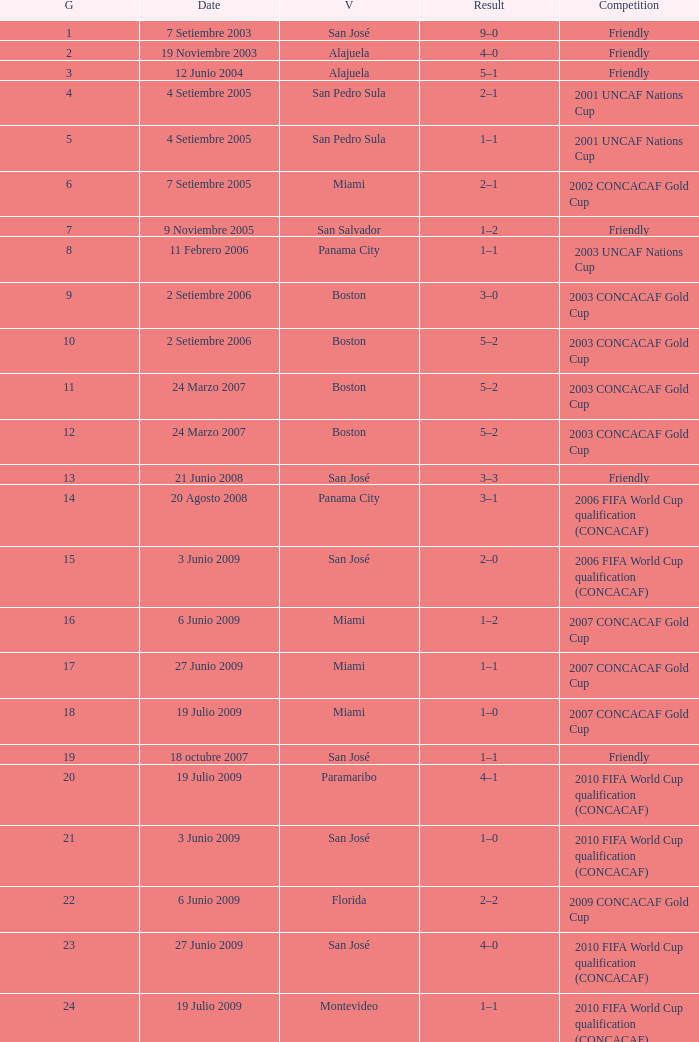Could you parse the entire table as a dict? {'header': ['G', 'Date', 'V', 'Result', 'Competition'], 'rows': [['1', '7 Setiembre 2003', 'San José', '9–0', 'Friendly'], ['2', '19 Noviembre 2003', 'Alajuela', '4–0', 'Friendly'], ['3', '12 Junio 2004', 'Alajuela', '5–1', 'Friendly'], ['4', '4 Setiembre 2005', 'San Pedro Sula', '2–1', '2001 UNCAF Nations Cup'], ['5', '4 Setiembre 2005', 'San Pedro Sula', '1–1', '2001 UNCAF Nations Cup'], ['6', '7 Setiembre 2005', 'Miami', '2–1', '2002 CONCACAF Gold Cup'], ['7', '9 Noviembre 2005', 'San Salvador', '1–2', 'Friendly'], ['8', '11 Febrero 2006', 'Panama City', '1–1', '2003 UNCAF Nations Cup'], ['9', '2 Setiembre 2006', 'Boston', '3–0', '2003 CONCACAF Gold Cup'], ['10', '2 Setiembre 2006', 'Boston', '5–2', '2003 CONCACAF Gold Cup'], ['11', '24 Marzo 2007', 'Boston', '5–2', '2003 CONCACAF Gold Cup'], ['12', '24 Marzo 2007', 'Boston', '5–2', '2003 CONCACAF Gold Cup'], ['13', '21 Junio 2008', 'San José', '3–3', 'Friendly'], ['14', '20 Agosto 2008', 'Panama City', '3–1', '2006 FIFA World Cup qualification (CONCACAF)'], ['15', '3 Junio 2009', 'San José', '2–0', '2006 FIFA World Cup qualification (CONCACAF)'], ['16', '6 Junio 2009', 'Miami', '1–2', '2007 CONCACAF Gold Cup'], ['17', '27 Junio 2009', 'Miami', '1–1', '2007 CONCACAF Gold Cup'], ['18', '19 Julio 2009', 'Miami', '1–0', '2007 CONCACAF Gold Cup'], ['19', '18 octubre 2007', 'San José', '1–1', 'Friendly'], ['20', '19 Julio 2009', 'Paramaribo', '4–1', '2010 FIFA World Cup qualification (CONCACAF)'], ['21', '3 Junio 2009', 'San José', '1–0', '2010 FIFA World Cup qualification (CONCACAF)'], ['22', '6 Junio 2009', 'Florida', '2–2', '2009 CONCACAF Gold Cup'], ['23', '27 Junio 2009', 'San José', '4–0', '2010 FIFA World Cup qualification (CONCACAF)'], ['24', '19 Julio 2009', 'Montevideo', '1–1', '2010 FIFA World Cup qualification (CONCACAF)']]} How was the competition in which 6 goals were made? 2002 CONCACAF Gold Cup. 